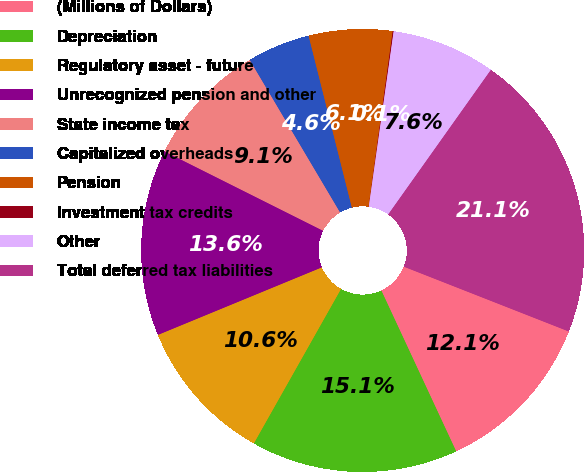<chart> <loc_0><loc_0><loc_500><loc_500><pie_chart><fcel>(Millions of Dollars)<fcel>Depreciation<fcel>Regulatory asset - future<fcel>Unrecognized pension and other<fcel>State income tax<fcel>Capitalized overheads<fcel>Pension<fcel>Investment tax credits<fcel>Other<fcel>Total deferred tax liabilities<nl><fcel>12.11%<fcel>15.11%<fcel>10.6%<fcel>13.61%<fcel>9.1%<fcel>4.59%<fcel>6.09%<fcel>0.07%<fcel>7.59%<fcel>21.13%<nl></chart> 